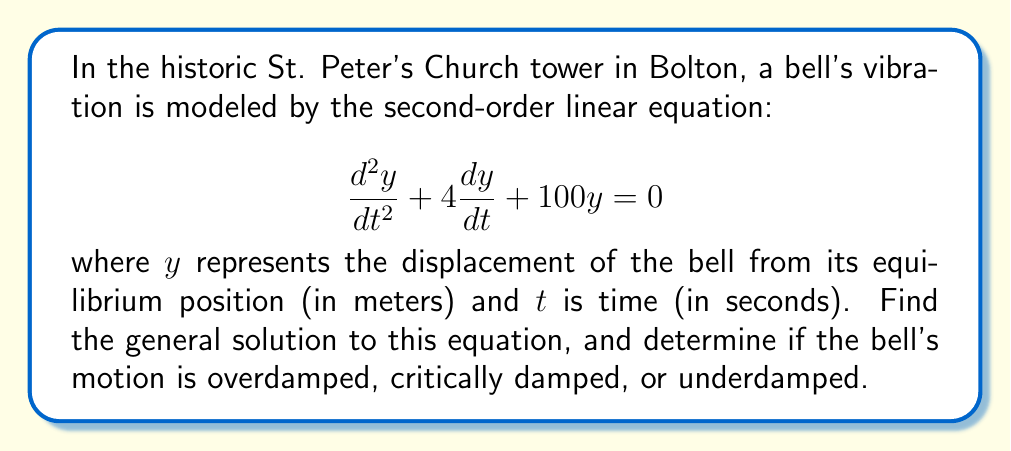Could you help me with this problem? To solve this second-order linear equation, we follow these steps:

1) The general form of a second-order linear equation is:
   $$\frac{d^2y}{dt^2} + 2\zeta\omega_n\frac{dy}{dt} + \omega_n^2y = 0$$
   where $\zeta$ is the damping ratio and $\omega_n$ is the natural frequency.

2) Comparing our equation to the general form, we see that:
   $2\zeta\omega_n = 4$ and $\omega_n^2 = 100$

3) From $\omega_n^2 = 100$, we get $\omega_n = 10$ rad/s

4) Substituting this into $2\zeta\omega_n = 4$, we get:
   $2\zeta(10) = 4$
   $\zeta = 0.2$

5) The characteristic equation is:
   $$r^2 + 4r + 100 = 0$$

6) Using the quadratic formula, $r = \frac{-b \pm \sqrt{b^2 - 4ac}}{2a}$, we get:
   $$r = \frac{-4 \pm \sqrt{16 - 400}}{2} = \frac{-4 \pm \sqrt{-384}}{2} = -2 \pm i\sqrt{96} = -2 \pm 4\sqrt{6}i$$

7) Since the roots are complex conjugates, the general solution is:
   $$y(t) = e^{-2t}(C_1\cos(4\sqrt{6}t) + C_2\sin(4\sqrt{6}t))$$
   where $C_1$ and $C_2$ are arbitrary constants.

8) To determine the type of damping, we compare $\zeta$ to 1:
   - If $\zeta > 1$, the system is overdamped
   - If $\zeta = 1$, the system is critically damped
   - If $0 < \zeta < 1$, the system is underdamped

   Since $\zeta = 0.2$, which is between 0 and 1, the system is underdamped.
Answer: The general solution is:
$$y(t) = e^{-2t}(C_1\cos(4\sqrt{6}t) + C_2\sin(4\sqrt{6}t))$$
The bell's motion is underdamped. 